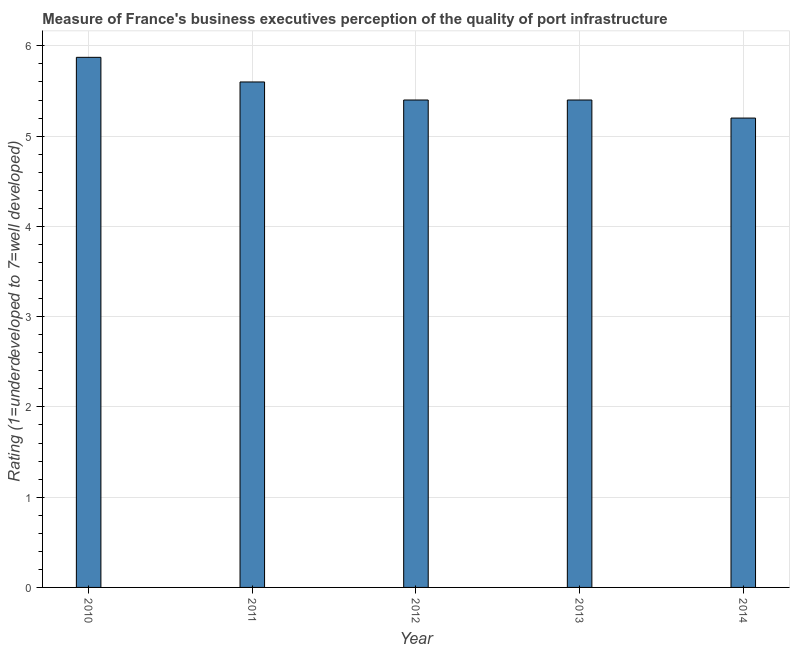Does the graph contain grids?
Your answer should be compact. Yes. What is the title of the graph?
Give a very brief answer. Measure of France's business executives perception of the quality of port infrastructure. What is the label or title of the X-axis?
Offer a very short reply. Year. What is the label or title of the Y-axis?
Provide a short and direct response. Rating (1=underdeveloped to 7=well developed) . What is the rating measuring quality of port infrastructure in 2014?
Give a very brief answer. 5.2. Across all years, what is the maximum rating measuring quality of port infrastructure?
Your answer should be very brief. 5.87. In which year was the rating measuring quality of port infrastructure minimum?
Offer a terse response. 2014. What is the sum of the rating measuring quality of port infrastructure?
Keep it short and to the point. 27.47. What is the difference between the rating measuring quality of port infrastructure in 2010 and 2014?
Provide a short and direct response. 0.67. What is the average rating measuring quality of port infrastructure per year?
Make the answer very short. 5.5. What is the difference between the highest and the second highest rating measuring quality of port infrastructure?
Make the answer very short. 0.27. What is the difference between the highest and the lowest rating measuring quality of port infrastructure?
Provide a succinct answer. 0.67. In how many years, is the rating measuring quality of port infrastructure greater than the average rating measuring quality of port infrastructure taken over all years?
Ensure brevity in your answer.  2. Are all the bars in the graph horizontal?
Offer a very short reply. No. What is the Rating (1=underdeveloped to 7=well developed)  of 2010?
Your response must be concise. 5.87. What is the Rating (1=underdeveloped to 7=well developed)  of 2012?
Offer a terse response. 5.4. What is the Rating (1=underdeveloped to 7=well developed)  in 2014?
Make the answer very short. 5.2. What is the difference between the Rating (1=underdeveloped to 7=well developed)  in 2010 and 2011?
Give a very brief answer. 0.27. What is the difference between the Rating (1=underdeveloped to 7=well developed)  in 2010 and 2012?
Keep it short and to the point. 0.47. What is the difference between the Rating (1=underdeveloped to 7=well developed)  in 2010 and 2013?
Your answer should be very brief. 0.47. What is the difference between the Rating (1=underdeveloped to 7=well developed)  in 2010 and 2014?
Your answer should be compact. 0.67. What is the difference between the Rating (1=underdeveloped to 7=well developed)  in 2011 and 2013?
Offer a very short reply. 0.2. What is the difference between the Rating (1=underdeveloped to 7=well developed)  in 2012 and 2013?
Make the answer very short. 0. What is the difference between the Rating (1=underdeveloped to 7=well developed)  in 2013 and 2014?
Keep it short and to the point. 0.2. What is the ratio of the Rating (1=underdeveloped to 7=well developed)  in 2010 to that in 2011?
Make the answer very short. 1.05. What is the ratio of the Rating (1=underdeveloped to 7=well developed)  in 2010 to that in 2012?
Offer a very short reply. 1.09. What is the ratio of the Rating (1=underdeveloped to 7=well developed)  in 2010 to that in 2013?
Ensure brevity in your answer.  1.09. What is the ratio of the Rating (1=underdeveloped to 7=well developed)  in 2010 to that in 2014?
Keep it short and to the point. 1.13. What is the ratio of the Rating (1=underdeveloped to 7=well developed)  in 2011 to that in 2013?
Offer a very short reply. 1.04. What is the ratio of the Rating (1=underdeveloped to 7=well developed)  in 2011 to that in 2014?
Your answer should be compact. 1.08. What is the ratio of the Rating (1=underdeveloped to 7=well developed)  in 2012 to that in 2014?
Give a very brief answer. 1.04. What is the ratio of the Rating (1=underdeveloped to 7=well developed)  in 2013 to that in 2014?
Give a very brief answer. 1.04. 